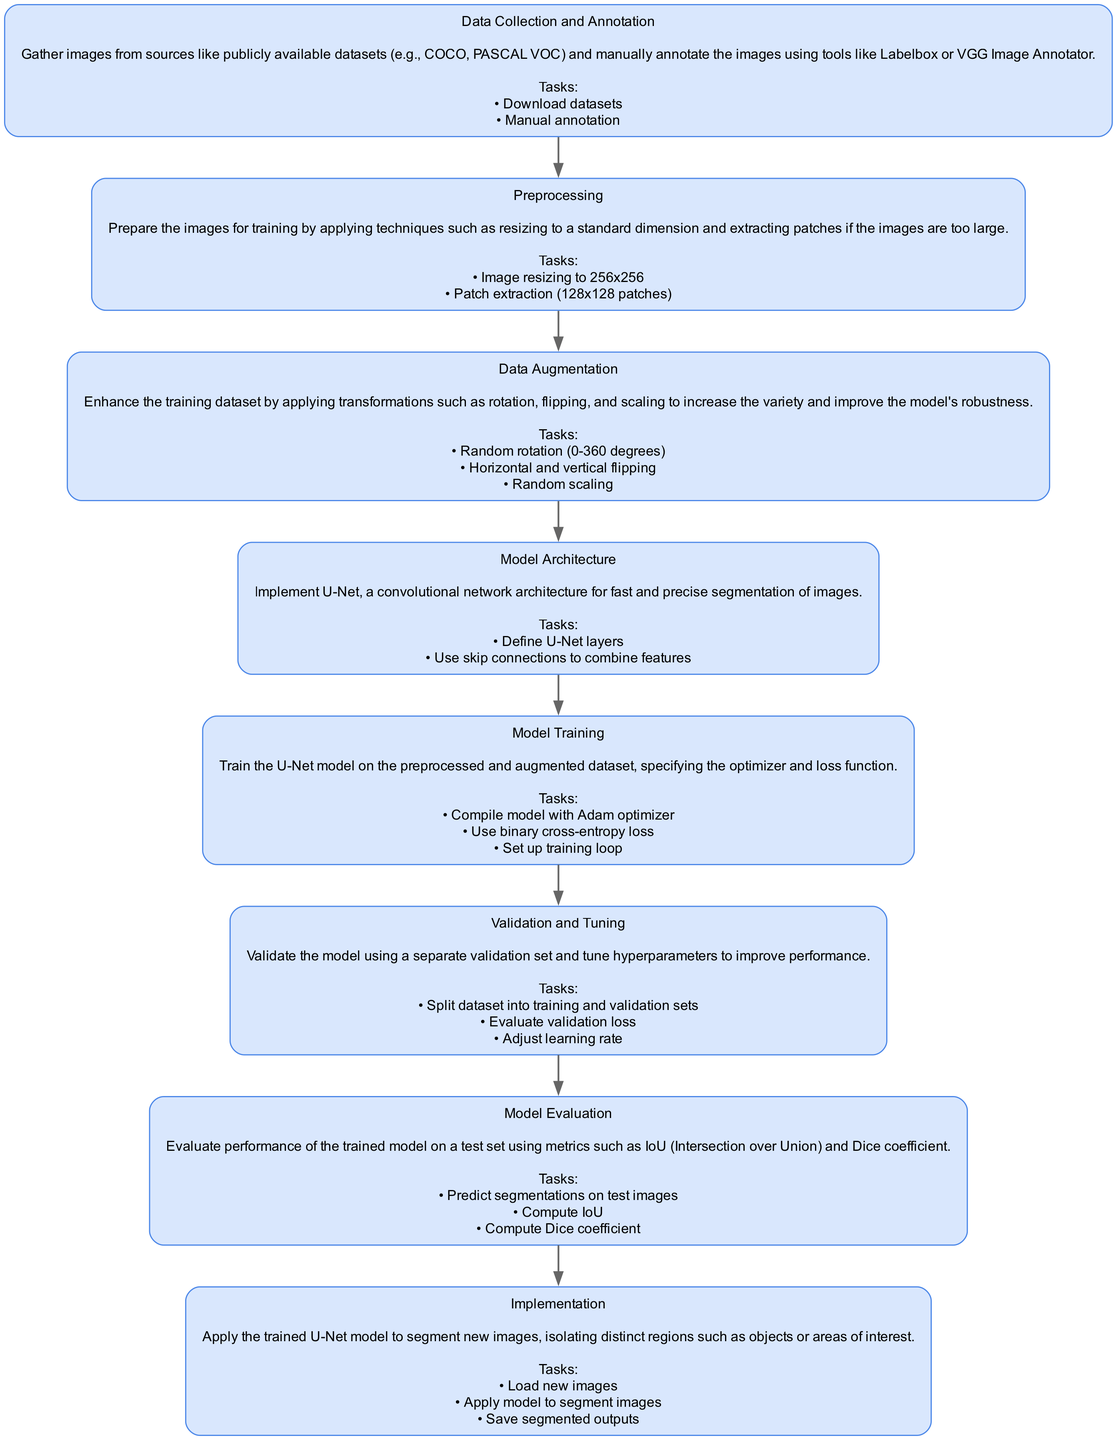What is the first stage in the flowchart? The flowchart begins with the "Data Collection and Annotation" stage. This is the first node in the diagram, indicating the starting point of the process.
Answer: Data Collection and Annotation How many tasks are listed under the "Model Training" stage? The "Model Training" stage includes three tasks listed in the flowchart. By counting them, we see that the tasks involved here are "Compile model with Adam optimizer," "Use binary cross-entropy loss," and "Set up training loop."
Answer: 3 What stage follows immediately after "Preprocessing"? After "Preprocessing," the next stage listed in the flowchart is "Data Augmentation." The flowchart direction indicates this flow of stages clearly.
Answer: Data Augmentation What is the purpose of the "Model Evaluation" stage? The "Model Evaluation" stage is described as evaluating the performance of the trained model on a test set. It involves computing metrics such as IoU and Dice coefficient to assess the model's effectiveness.
Answer: Evaluate performance List two tasks involved in the "Preprocessing" stage. The "Preprocessing" stage consists of the tasks: "Image resizing to 256x256" and "Patch extraction (128x128 patches)." These tasks prepare the images for further processing in the training pipeline.
Answer: Image resizing to 256x256, Patch extraction (128x128 patches) What stage is focused on fine-tuning the model? The stage dedicated to fine-tuning the model is "Validation and Tuning." This stage specifically addresses tuning hyperparameters and evaluating validation loss to improve the model's performance.
Answer: Validation and Tuning How many total stages are present in the flowchart? The flowchart includes a total of eight distinct stages, starting from "Data Collection and Annotation" to "Implementation." Counting each stage confirms this total.
Answer: 8 What transformation types are applied in the "Data Augmentation" stage? The transformations applied in the "Data Augmentation" stage include random rotation, flipping (both horizontal and vertical), and random scaling. This aims to increase dataset variety and model robustness.
Answer: Random rotation, Flipping, Random scaling What is the output task in the "Implementation" stage? The main output task in the "Implementation" stage is applying the trained U-Net model to segment new images and saving the segmented outputs. This indicates the practical application of the trained model.
Answer: Apply model to segment images, Save segmented outputs 